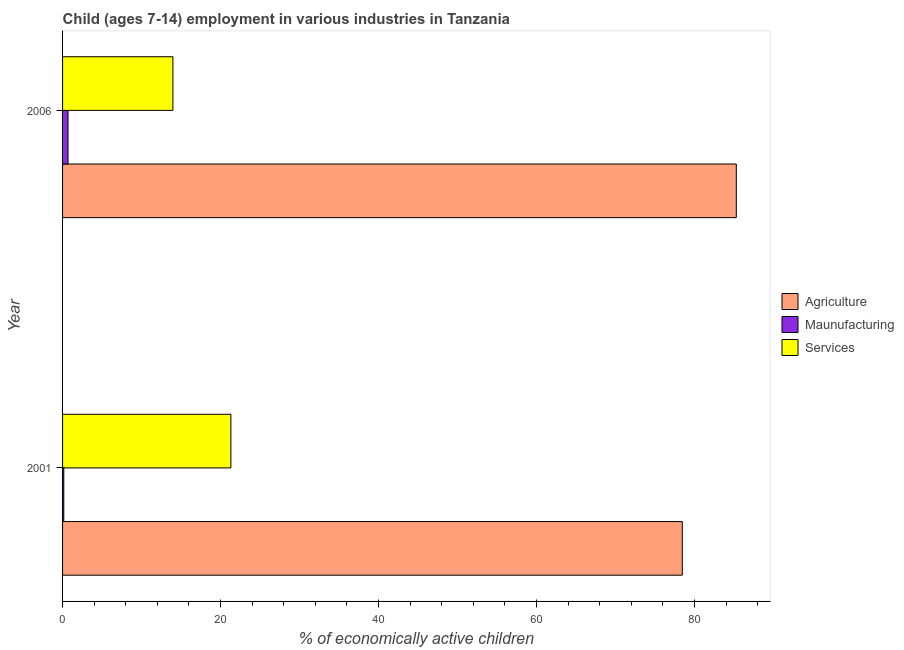In how many cases, is the number of bars for a given year not equal to the number of legend labels?
Your answer should be compact. 0. What is the percentage of economically active children in services in 2006?
Provide a short and direct response. 13.97. Across all years, what is the maximum percentage of economically active children in agriculture?
Provide a short and direct response. 85.3. Across all years, what is the minimum percentage of economically active children in manufacturing?
Provide a succinct answer. 0.15. In which year was the percentage of economically active children in agriculture maximum?
Your answer should be compact. 2006. In which year was the percentage of economically active children in agriculture minimum?
Keep it short and to the point. 2001. What is the total percentage of economically active children in services in the graph?
Offer a terse response. 35.28. What is the difference between the percentage of economically active children in services in 2001 and that in 2006?
Provide a succinct answer. 7.34. What is the difference between the percentage of economically active children in agriculture in 2001 and the percentage of economically active children in services in 2006?
Give a very brief answer. 64.49. What is the average percentage of economically active children in agriculture per year?
Keep it short and to the point. 81.88. In the year 2006, what is the difference between the percentage of economically active children in manufacturing and percentage of economically active children in agriculture?
Offer a terse response. -84.61. In how many years, is the percentage of economically active children in services greater than 12 %?
Your answer should be very brief. 2. What is the ratio of the percentage of economically active children in manufacturing in 2001 to that in 2006?
Provide a succinct answer. 0.22. Is the percentage of economically active children in manufacturing in 2001 less than that in 2006?
Provide a short and direct response. Yes. In how many years, is the percentage of economically active children in agriculture greater than the average percentage of economically active children in agriculture taken over all years?
Provide a short and direct response. 1. What does the 3rd bar from the top in 2006 represents?
Keep it short and to the point. Agriculture. What does the 3rd bar from the bottom in 2006 represents?
Your response must be concise. Services. How many bars are there?
Ensure brevity in your answer.  6. Are all the bars in the graph horizontal?
Keep it short and to the point. Yes. How many years are there in the graph?
Keep it short and to the point. 2. What is the difference between two consecutive major ticks on the X-axis?
Offer a very short reply. 20. Does the graph contain any zero values?
Ensure brevity in your answer.  No. Does the graph contain grids?
Your answer should be compact. No. What is the title of the graph?
Offer a terse response. Child (ages 7-14) employment in various industries in Tanzania. What is the label or title of the X-axis?
Your answer should be compact. % of economically active children. What is the label or title of the Y-axis?
Keep it short and to the point. Year. What is the % of economically active children of Agriculture in 2001?
Provide a succinct answer. 78.46. What is the % of economically active children of Maunufacturing in 2001?
Your answer should be compact. 0.15. What is the % of economically active children in Services in 2001?
Keep it short and to the point. 21.31. What is the % of economically active children in Agriculture in 2006?
Provide a short and direct response. 85.3. What is the % of economically active children of Maunufacturing in 2006?
Offer a terse response. 0.69. What is the % of economically active children of Services in 2006?
Give a very brief answer. 13.97. Across all years, what is the maximum % of economically active children of Agriculture?
Give a very brief answer. 85.3. Across all years, what is the maximum % of economically active children in Maunufacturing?
Make the answer very short. 0.69. Across all years, what is the maximum % of economically active children in Services?
Your answer should be compact. 21.31. Across all years, what is the minimum % of economically active children in Agriculture?
Your answer should be very brief. 78.46. Across all years, what is the minimum % of economically active children in Maunufacturing?
Keep it short and to the point. 0.15. Across all years, what is the minimum % of economically active children in Services?
Your answer should be compact. 13.97. What is the total % of economically active children in Agriculture in the graph?
Give a very brief answer. 163.76. What is the total % of economically active children in Maunufacturing in the graph?
Give a very brief answer. 0.84. What is the total % of economically active children of Services in the graph?
Provide a short and direct response. 35.28. What is the difference between the % of economically active children of Agriculture in 2001 and that in 2006?
Offer a very short reply. -6.84. What is the difference between the % of economically active children in Maunufacturing in 2001 and that in 2006?
Offer a very short reply. -0.54. What is the difference between the % of economically active children of Services in 2001 and that in 2006?
Ensure brevity in your answer.  7.34. What is the difference between the % of economically active children of Agriculture in 2001 and the % of economically active children of Maunufacturing in 2006?
Provide a succinct answer. 77.77. What is the difference between the % of economically active children in Agriculture in 2001 and the % of economically active children in Services in 2006?
Your response must be concise. 64.49. What is the difference between the % of economically active children of Maunufacturing in 2001 and the % of economically active children of Services in 2006?
Your answer should be very brief. -13.82. What is the average % of economically active children in Agriculture per year?
Your answer should be compact. 81.88. What is the average % of economically active children of Maunufacturing per year?
Your answer should be very brief. 0.42. What is the average % of economically active children in Services per year?
Provide a short and direct response. 17.64. In the year 2001, what is the difference between the % of economically active children in Agriculture and % of economically active children in Maunufacturing?
Provide a succinct answer. 78.31. In the year 2001, what is the difference between the % of economically active children in Agriculture and % of economically active children in Services?
Offer a terse response. 57.15. In the year 2001, what is the difference between the % of economically active children in Maunufacturing and % of economically active children in Services?
Keep it short and to the point. -21.16. In the year 2006, what is the difference between the % of economically active children in Agriculture and % of economically active children in Maunufacturing?
Keep it short and to the point. 84.61. In the year 2006, what is the difference between the % of economically active children in Agriculture and % of economically active children in Services?
Offer a terse response. 71.33. In the year 2006, what is the difference between the % of economically active children of Maunufacturing and % of economically active children of Services?
Give a very brief answer. -13.28. What is the ratio of the % of economically active children in Agriculture in 2001 to that in 2006?
Make the answer very short. 0.92. What is the ratio of the % of economically active children of Maunufacturing in 2001 to that in 2006?
Your answer should be compact. 0.22. What is the ratio of the % of economically active children of Services in 2001 to that in 2006?
Your response must be concise. 1.53. What is the difference between the highest and the second highest % of economically active children of Agriculture?
Give a very brief answer. 6.84. What is the difference between the highest and the second highest % of economically active children of Maunufacturing?
Your response must be concise. 0.54. What is the difference between the highest and the second highest % of economically active children in Services?
Your answer should be compact. 7.34. What is the difference between the highest and the lowest % of economically active children of Agriculture?
Offer a very short reply. 6.84. What is the difference between the highest and the lowest % of economically active children in Maunufacturing?
Keep it short and to the point. 0.54. What is the difference between the highest and the lowest % of economically active children of Services?
Keep it short and to the point. 7.34. 